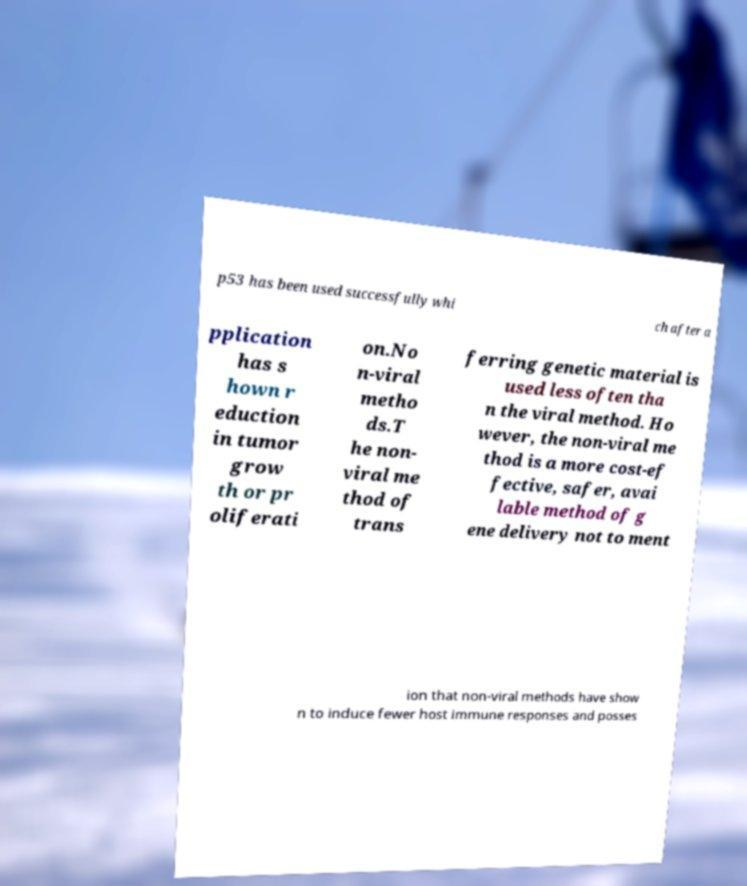There's text embedded in this image that I need extracted. Can you transcribe it verbatim? p53 has been used successfully whi ch after a pplication has s hown r eduction in tumor grow th or pr oliferati on.No n-viral metho ds.T he non- viral me thod of trans ferring genetic material is used less often tha n the viral method. Ho wever, the non-viral me thod is a more cost-ef fective, safer, avai lable method of g ene delivery not to ment ion that non-viral methods have show n to induce fewer host immune responses and posses 